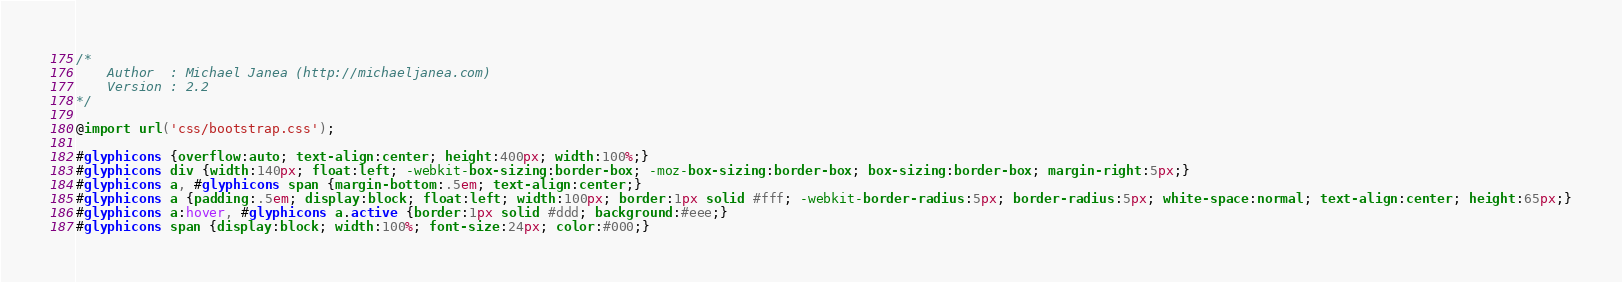<code> <loc_0><loc_0><loc_500><loc_500><_CSS_>/*
	Author	: Michael Janea (http://michaeljanea.com)
	Version	: 2.2
*/

@import url('css/bootstrap.css');

#glyphicons {overflow:auto; text-align:center; height:400px; width:100%;}
#glyphicons div {width:140px; float:left; -webkit-box-sizing:border-box; -moz-box-sizing:border-box; box-sizing:border-box; margin-right:5px;}
#glyphicons a, #glyphicons span {margin-bottom:.5em; text-align:center;}
#glyphicons a {padding:.5em; display:block; float:left; width:100px; border:1px solid #fff; -webkit-border-radius:5px; border-radius:5px; white-space:normal; text-align:center; height:65px;}
#glyphicons a:hover, #glyphicons a.active {border:1px solid #ddd; background:#eee;}
#glyphicons span {display:block; width:100%; font-size:24px; color:#000;}
</code> 